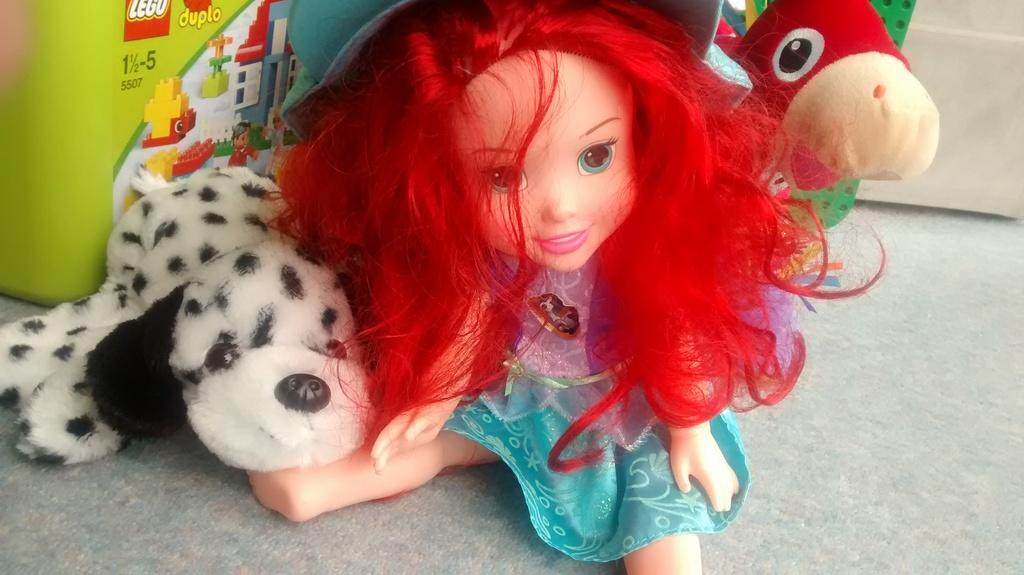What type of toys are on the floor in the image? There is a baby girl toy, a dog toy, and a bird toy on the floor. Can you describe the baby girl toy? The baby girl toy is a toy meant to represent a baby girl. What other type of toy is on the floor? There is also a dog toy and a bird toy on the floor. What type of punishment is the baby girl toy receiving in the image? There is no indication of punishment in the image; it simply shows the toys on the floor. Can you recite a verse from the bird toy in the image? There is no mention of a verse or any speaking ability for the toys in the image. 